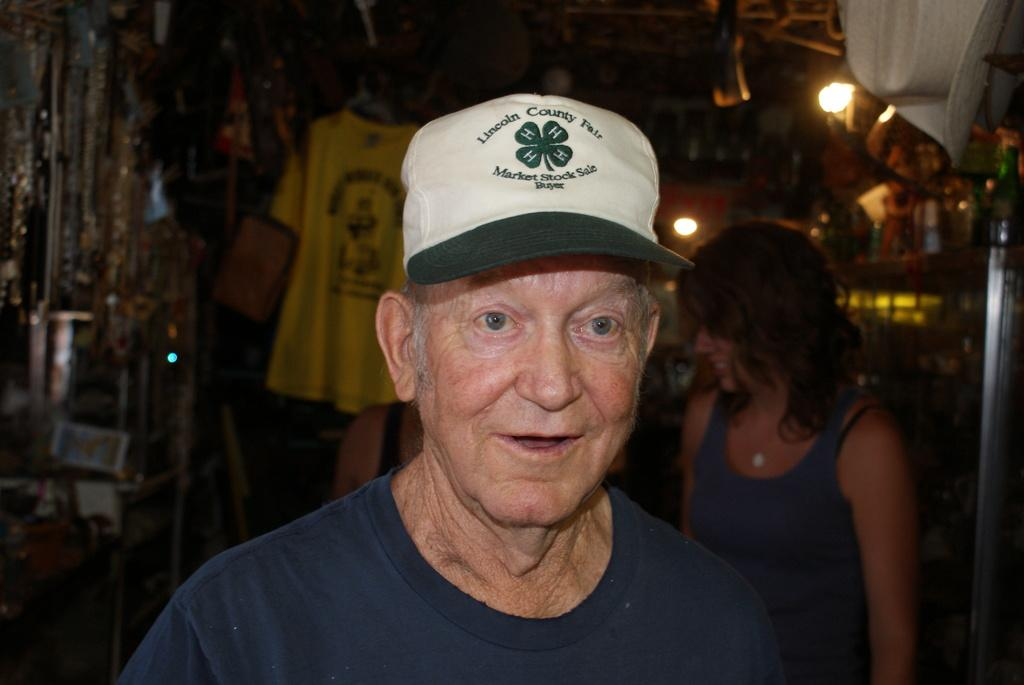Who is the main subject in the image? There is an old man in the image. What is the old man doing in the image? The old man is smiling. What is the old man wearing in the image? The old man is wearing a cap. Can you describe the background of the image? The background of the image is blurred. What can be seen in the image besides the old man? There are lights, people, and things visible in the image. What type of unit is being measured in the image? There is no unit being measured in the image; it features an old man, lights, people, and things. Can you tell me how many basins are visible in the image? There are no basins visible in the image. 